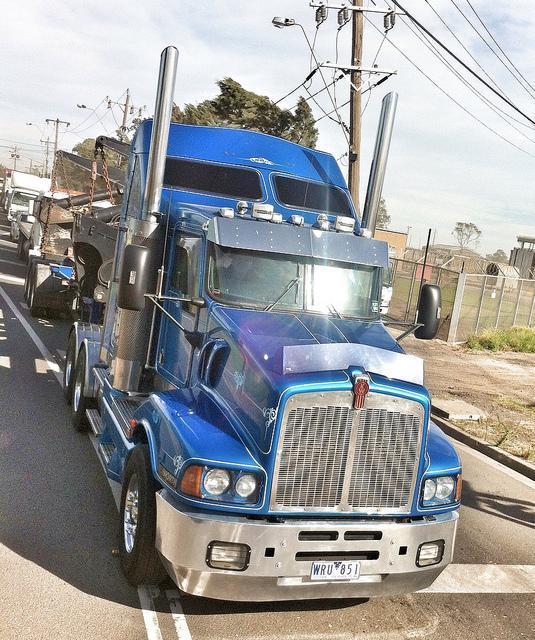How many oxygen tubes is the man in the bed wearing?
Give a very brief answer. 0. 